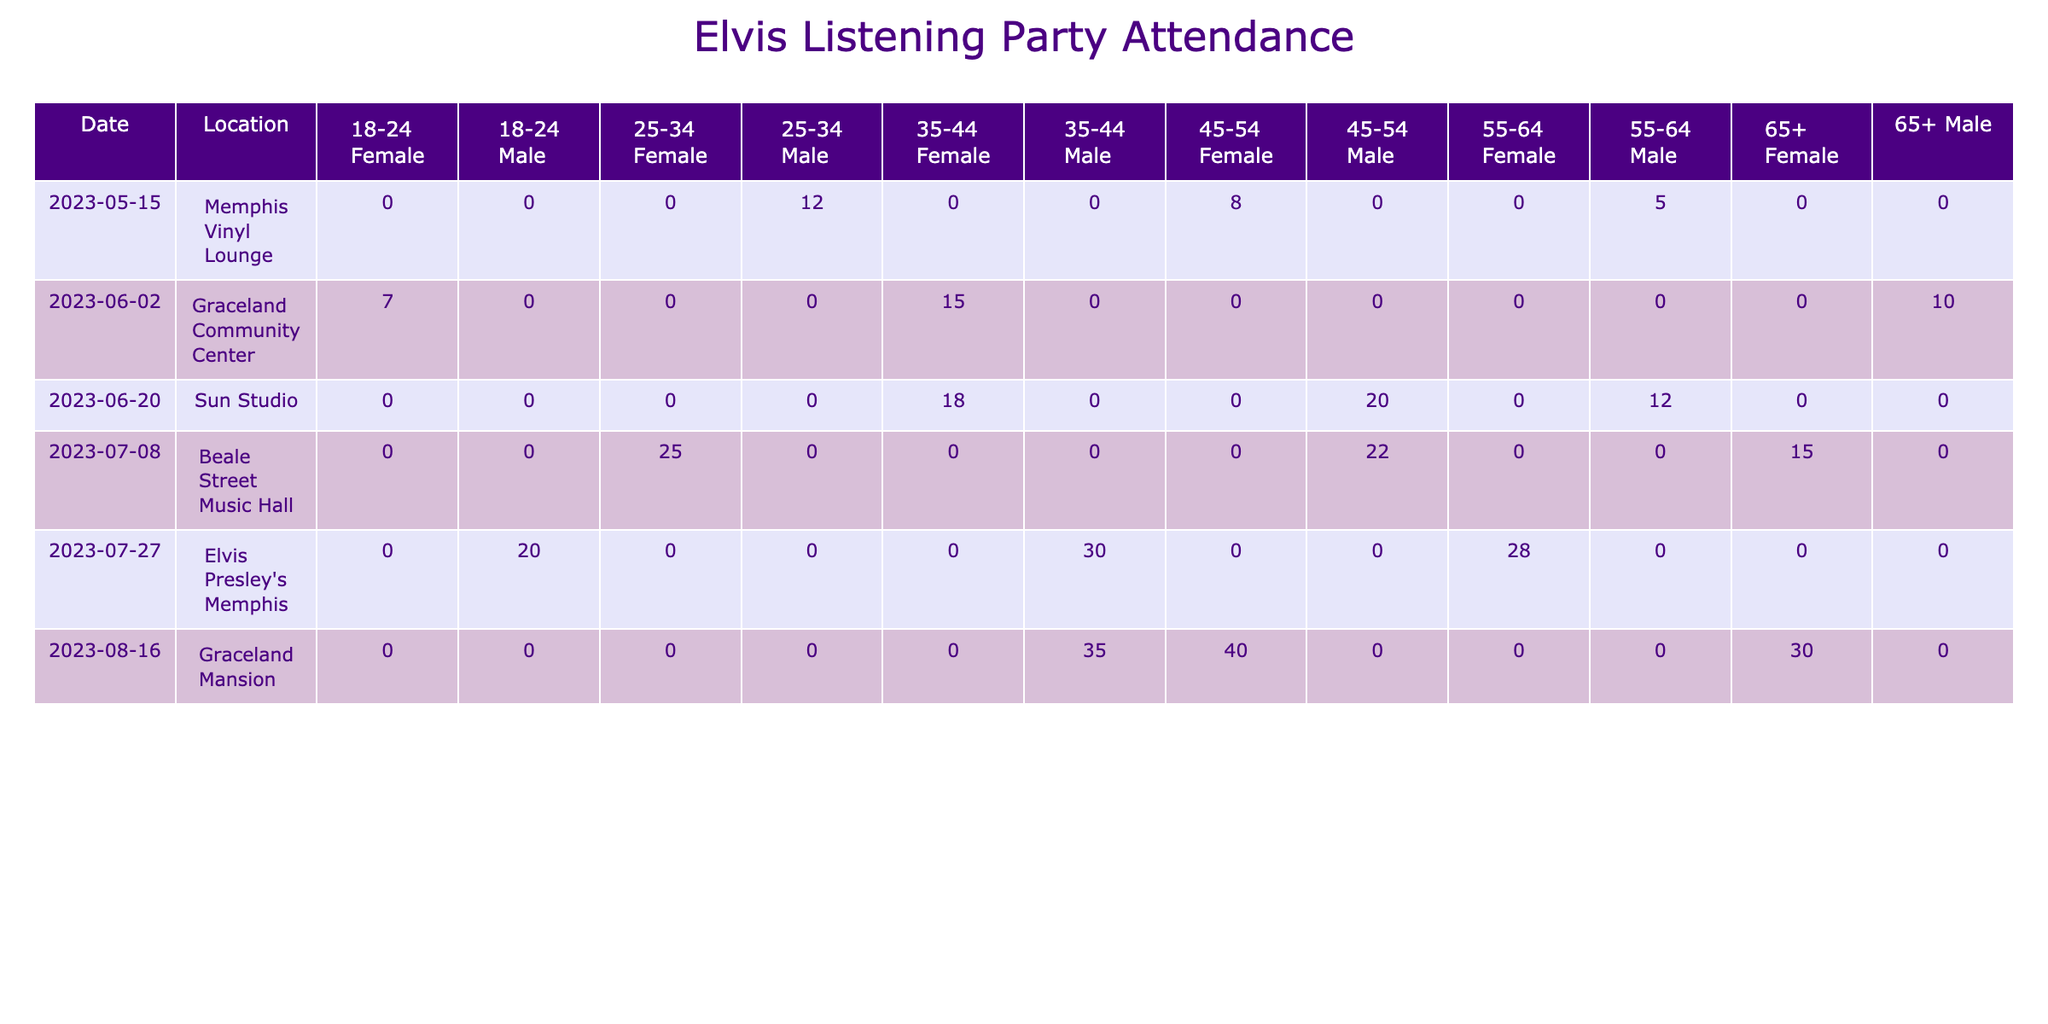What was the total number of attendees at the listening party held at Graceland Community Center on June 2, 2023? To find the total number of attendees for that date and location, I look at the "Attendees" column for the rows matching these criteria. The attendees were 15 (35-44, Female) + 10 (65+, Male) + 7 (18-24, Female) = 32.
Answer: 32 How many female attendees aged 45-54 were present at the Beale Street Music Hall on July 8, 2023? I check the rows for July 8, 2023, at Beale Street Music Hall and find only one entry that matches: 15 (65+, Female with the 1970s). Therefore, there were no female attendees aged 45-54 at this event.
Answer: 0 What is the total number of attendees who favored the 1960s Elvis era across all events? I sum the attendees from all rows where the favorite Elvis era is 1960s. The values are: 8 (Memphis Vinyl Lounge) + 15 (Graceland Community Center) + 20 (Sun Studio) + 25 (Beale Street Music Hall) + 30 (Elvis Presley's Memphis) + 35 (Graceland Mansion) = 133.
Answer: 133 Did the Sun Studio event on June 20, 2023, have more male attendees than female attendees? For this event, the male attendees total 20 (45-54) + 12 (55-64) = 32, while female attendees total 18 (35-44) = 18. Since 32 is greater than 18, the answer is yes.
Answer: Yes What was the average number of attendees for the listening parties held at Graceland Mansion? First, identify the events at Graceland Mansion: on August 16, 2023, there were 40 (45-54, Female), 35 (35-44, Male), and 30 (65+, Female) attendees. There are three events, so the average is (40 + 35 + 30) / 3 = 35.
Answer: 35 